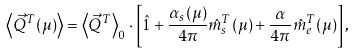Convert formula to latex. <formula><loc_0><loc_0><loc_500><loc_500>\left \langle \vec { Q } ^ { T } ( \mu ) \right \rangle = \left \langle \vec { Q } ^ { T } \right \rangle _ { 0 } \cdot \left [ \hat { 1 } + \frac { \alpha _ { s } ( \mu ) } { 4 \pi } \hat { m } ^ { T } _ { s } ( \mu ) + \frac { \alpha } { 4 \pi } \hat { m } ^ { T } _ { e } ( \mu ) \right ] ,</formula> 